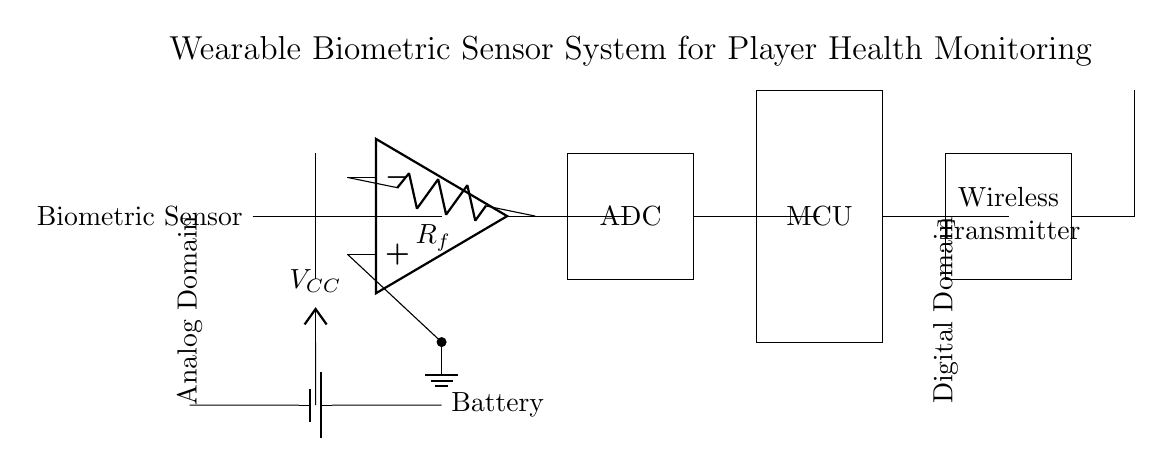What type of sensor is used in this circuit? The circuit diagram labels the first component as a "Biometric Sensor," indicating it is responsible for monitoring health metrics.
Answer: Biometric Sensor What does ADC in the circuit stand for? The rectangle labeled "ADC" signifies an Analog to Digital Converter, which converts analog signals from the sensor into digital signals for processing.
Answer: Analog to Digital Converter What is the power source of this circuit? The circuit shows a "Battery" connected to the circuit, which supplies power to the components.
Answer: Battery How many main functional blocks are present in this circuit? By visually inspecting the circuit, there are five main blocks: Biometric Sensor, Amplifier, ADC, Microcontroller, and Wireless Transmitter.
Answer: Five What type of components are connected to the analog domain? The "Analog Domain" label indicates that all components prior to the Microcontroller, such as the sensor, amplifier, and ADC, fall within this category.
Answer: Biometric Sensor, Amplifier, ADC What is the function of the Microcontroller in this circuit? The Microcontroller (MCU) processes the digital data received from the ADC and controls the operation of the wireless transmitter.
Answer: Process data and control What additional component is seen attached to the Wireless Transmitter? The circuit shows an "Antenna" attached to the Wireless Transmitter, indicating the means of wireless communication for sending data.
Answer: Antenna 